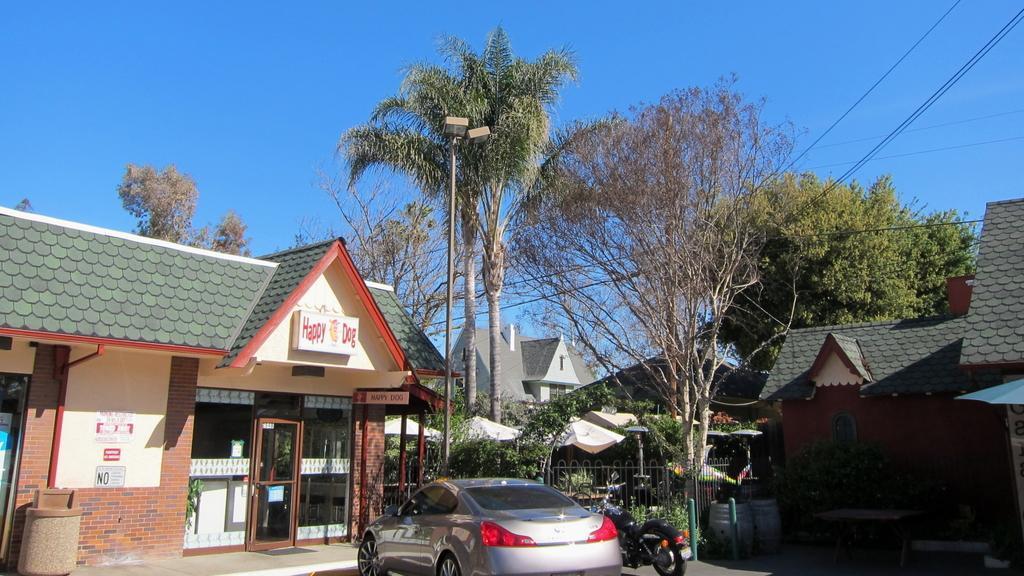In one or two sentences, can you explain what this image depicts? In this picture I can see a car and a bike in front and in the middle of this picture I see number of buildings, plants, wires, a pole and number of trees. In the background I see the clear sky. 